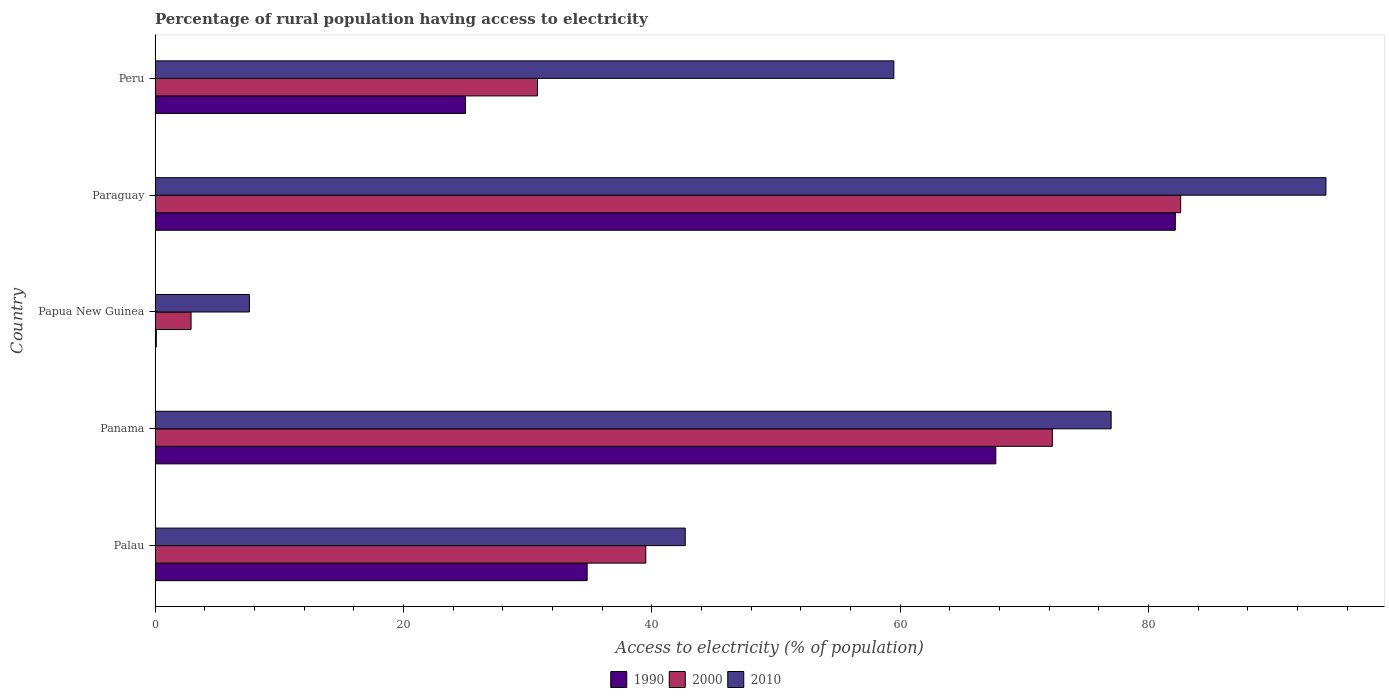How many different coloured bars are there?
Your response must be concise. 3. What is the label of the 2nd group of bars from the top?
Give a very brief answer. Paraguay. In how many cases, is the number of bars for a given country not equal to the number of legend labels?
Ensure brevity in your answer.  0. What is the percentage of rural population having access to electricity in 1990 in Paraguay?
Make the answer very short. 82.17. Across all countries, what is the maximum percentage of rural population having access to electricity in 1990?
Provide a short and direct response. 82.17. In which country was the percentage of rural population having access to electricity in 1990 maximum?
Offer a very short reply. Paraguay. In which country was the percentage of rural population having access to electricity in 2000 minimum?
Give a very brief answer. Papua New Guinea. What is the total percentage of rural population having access to electricity in 2000 in the graph?
Ensure brevity in your answer.  228.09. What is the difference between the percentage of rural population having access to electricity in 2000 in Panama and that in Paraguay?
Make the answer very short. -10.33. What is the difference between the percentage of rural population having access to electricity in 1990 in Papua New Guinea and the percentage of rural population having access to electricity in 2010 in Palau?
Make the answer very short. -42.6. What is the average percentage of rural population having access to electricity in 2010 per country?
Ensure brevity in your answer.  56.22. What is the difference between the percentage of rural population having access to electricity in 2000 and percentage of rural population having access to electricity in 1990 in Peru?
Provide a succinct answer. 5.8. In how many countries, is the percentage of rural population having access to electricity in 1990 greater than 8 %?
Your answer should be very brief. 4. What is the ratio of the percentage of rural population having access to electricity in 2000 in Panama to that in Papua New Guinea?
Make the answer very short. 24.92. Is the difference between the percentage of rural population having access to electricity in 2000 in Panama and Paraguay greater than the difference between the percentage of rural population having access to electricity in 1990 in Panama and Paraguay?
Give a very brief answer. Yes. What is the difference between the highest and the second highest percentage of rural population having access to electricity in 2010?
Ensure brevity in your answer.  17.3. What is the difference between the highest and the lowest percentage of rural population having access to electricity in 2010?
Your answer should be compact. 86.7. Is the sum of the percentage of rural population having access to electricity in 1990 in Papua New Guinea and Paraguay greater than the maximum percentage of rural population having access to electricity in 2000 across all countries?
Offer a terse response. No. What does the 3rd bar from the bottom in Peru represents?
Keep it short and to the point. 2010. Are all the bars in the graph horizontal?
Give a very brief answer. Yes. How many countries are there in the graph?
Your response must be concise. 5. What is the difference between two consecutive major ticks on the X-axis?
Offer a very short reply. 20. Where does the legend appear in the graph?
Your response must be concise. Bottom center. How are the legend labels stacked?
Keep it short and to the point. Horizontal. What is the title of the graph?
Offer a terse response. Percentage of rural population having access to electricity. Does "2013" appear as one of the legend labels in the graph?
Your response must be concise. No. What is the label or title of the X-axis?
Give a very brief answer. Access to electricity (% of population). What is the label or title of the Y-axis?
Provide a succinct answer. Country. What is the Access to electricity (% of population) in 1990 in Palau?
Your answer should be compact. 34.8. What is the Access to electricity (% of population) in 2000 in Palau?
Your answer should be compact. 39.52. What is the Access to electricity (% of population) of 2010 in Palau?
Your answer should be very brief. 42.7. What is the Access to electricity (% of population) in 1990 in Panama?
Make the answer very short. 67.71. What is the Access to electricity (% of population) of 2000 in Panama?
Your answer should be very brief. 72.27. What is the Access to electricity (% of population) of 2010 in Panama?
Provide a succinct answer. 77. What is the Access to electricity (% of population) of 2000 in Papua New Guinea?
Keep it short and to the point. 2.9. What is the Access to electricity (% of population) in 2010 in Papua New Guinea?
Provide a short and direct response. 7.6. What is the Access to electricity (% of population) in 1990 in Paraguay?
Make the answer very short. 82.17. What is the Access to electricity (% of population) of 2000 in Paraguay?
Provide a succinct answer. 82.6. What is the Access to electricity (% of population) of 2010 in Paraguay?
Provide a short and direct response. 94.3. What is the Access to electricity (% of population) in 1990 in Peru?
Your answer should be compact. 25. What is the Access to electricity (% of population) of 2000 in Peru?
Ensure brevity in your answer.  30.8. What is the Access to electricity (% of population) of 2010 in Peru?
Give a very brief answer. 59.5. Across all countries, what is the maximum Access to electricity (% of population) of 1990?
Give a very brief answer. 82.17. Across all countries, what is the maximum Access to electricity (% of population) in 2000?
Ensure brevity in your answer.  82.6. Across all countries, what is the maximum Access to electricity (% of population) in 2010?
Offer a very short reply. 94.3. Across all countries, what is the minimum Access to electricity (% of population) in 2000?
Your answer should be very brief. 2.9. Across all countries, what is the minimum Access to electricity (% of population) of 2010?
Ensure brevity in your answer.  7.6. What is the total Access to electricity (% of population) of 1990 in the graph?
Your answer should be very brief. 209.78. What is the total Access to electricity (% of population) in 2000 in the graph?
Offer a very short reply. 228.09. What is the total Access to electricity (% of population) in 2010 in the graph?
Make the answer very short. 281.1. What is the difference between the Access to electricity (% of population) of 1990 in Palau and that in Panama?
Provide a succinct answer. -32.91. What is the difference between the Access to electricity (% of population) of 2000 in Palau and that in Panama?
Provide a succinct answer. -32.74. What is the difference between the Access to electricity (% of population) of 2010 in Palau and that in Panama?
Provide a succinct answer. -34.3. What is the difference between the Access to electricity (% of population) in 1990 in Palau and that in Papua New Guinea?
Keep it short and to the point. 34.7. What is the difference between the Access to electricity (% of population) in 2000 in Palau and that in Papua New Guinea?
Provide a short and direct response. 36.62. What is the difference between the Access to electricity (% of population) of 2010 in Palau and that in Papua New Guinea?
Ensure brevity in your answer.  35.1. What is the difference between the Access to electricity (% of population) in 1990 in Palau and that in Paraguay?
Offer a very short reply. -47.37. What is the difference between the Access to electricity (% of population) in 2000 in Palau and that in Paraguay?
Offer a terse response. -43.08. What is the difference between the Access to electricity (% of population) of 2010 in Palau and that in Paraguay?
Offer a terse response. -51.6. What is the difference between the Access to electricity (% of population) in 1990 in Palau and that in Peru?
Keep it short and to the point. 9.8. What is the difference between the Access to electricity (% of population) of 2000 in Palau and that in Peru?
Provide a short and direct response. 8.72. What is the difference between the Access to electricity (% of population) of 2010 in Palau and that in Peru?
Ensure brevity in your answer.  -16.8. What is the difference between the Access to electricity (% of population) in 1990 in Panama and that in Papua New Guinea?
Make the answer very short. 67.61. What is the difference between the Access to electricity (% of population) of 2000 in Panama and that in Papua New Guinea?
Offer a terse response. 69.36. What is the difference between the Access to electricity (% of population) in 2010 in Panama and that in Papua New Guinea?
Ensure brevity in your answer.  69.4. What is the difference between the Access to electricity (% of population) of 1990 in Panama and that in Paraguay?
Offer a very short reply. -14.46. What is the difference between the Access to electricity (% of population) of 2000 in Panama and that in Paraguay?
Make the answer very short. -10.34. What is the difference between the Access to electricity (% of population) of 2010 in Panama and that in Paraguay?
Keep it short and to the point. -17.3. What is the difference between the Access to electricity (% of population) of 1990 in Panama and that in Peru?
Keep it short and to the point. 42.71. What is the difference between the Access to electricity (% of population) of 2000 in Panama and that in Peru?
Your answer should be very brief. 41.47. What is the difference between the Access to electricity (% of population) in 1990 in Papua New Guinea and that in Paraguay?
Provide a short and direct response. -82.07. What is the difference between the Access to electricity (% of population) in 2000 in Papua New Guinea and that in Paraguay?
Make the answer very short. -79.7. What is the difference between the Access to electricity (% of population) in 2010 in Papua New Guinea and that in Paraguay?
Ensure brevity in your answer.  -86.7. What is the difference between the Access to electricity (% of population) of 1990 in Papua New Guinea and that in Peru?
Provide a succinct answer. -24.9. What is the difference between the Access to electricity (% of population) in 2000 in Papua New Guinea and that in Peru?
Keep it short and to the point. -27.9. What is the difference between the Access to electricity (% of population) in 2010 in Papua New Guinea and that in Peru?
Your response must be concise. -51.9. What is the difference between the Access to electricity (% of population) of 1990 in Paraguay and that in Peru?
Your answer should be very brief. 57.17. What is the difference between the Access to electricity (% of population) of 2000 in Paraguay and that in Peru?
Your answer should be very brief. 51.8. What is the difference between the Access to electricity (% of population) in 2010 in Paraguay and that in Peru?
Make the answer very short. 34.8. What is the difference between the Access to electricity (% of population) in 1990 in Palau and the Access to electricity (% of population) in 2000 in Panama?
Keep it short and to the point. -37.47. What is the difference between the Access to electricity (% of population) of 1990 in Palau and the Access to electricity (% of population) of 2010 in Panama?
Offer a very short reply. -42.2. What is the difference between the Access to electricity (% of population) of 2000 in Palau and the Access to electricity (% of population) of 2010 in Panama?
Provide a succinct answer. -37.48. What is the difference between the Access to electricity (% of population) of 1990 in Palau and the Access to electricity (% of population) of 2000 in Papua New Guinea?
Give a very brief answer. 31.9. What is the difference between the Access to electricity (% of population) of 1990 in Palau and the Access to electricity (% of population) of 2010 in Papua New Guinea?
Offer a terse response. 27.2. What is the difference between the Access to electricity (% of population) of 2000 in Palau and the Access to electricity (% of population) of 2010 in Papua New Guinea?
Give a very brief answer. 31.92. What is the difference between the Access to electricity (% of population) in 1990 in Palau and the Access to electricity (% of population) in 2000 in Paraguay?
Give a very brief answer. -47.8. What is the difference between the Access to electricity (% of population) of 1990 in Palau and the Access to electricity (% of population) of 2010 in Paraguay?
Your answer should be very brief. -59.5. What is the difference between the Access to electricity (% of population) of 2000 in Palau and the Access to electricity (% of population) of 2010 in Paraguay?
Offer a very short reply. -54.78. What is the difference between the Access to electricity (% of population) of 1990 in Palau and the Access to electricity (% of population) of 2000 in Peru?
Make the answer very short. 4. What is the difference between the Access to electricity (% of population) in 1990 in Palau and the Access to electricity (% of population) in 2010 in Peru?
Offer a terse response. -24.7. What is the difference between the Access to electricity (% of population) of 2000 in Palau and the Access to electricity (% of population) of 2010 in Peru?
Offer a very short reply. -19.98. What is the difference between the Access to electricity (% of population) in 1990 in Panama and the Access to electricity (% of population) in 2000 in Papua New Guinea?
Give a very brief answer. 64.81. What is the difference between the Access to electricity (% of population) of 1990 in Panama and the Access to electricity (% of population) of 2010 in Papua New Guinea?
Provide a succinct answer. 60.11. What is the difference between the Access to electricity (% of population) in 2000 in Panama and the Access to electricity (% of population) in 2010 in Papua New Guinea?
Your response must be concise. 64.67. What is the difference between the Access to electricity (% of population) of 1990 in Panama and the Access to electricity (% of population) of 2000 in Paraguay?
Your answer should be very brief. -14.89. What is the difference between the Access to electricity (% of population) of 1990 in Panama and the Access to electricity (% of population) of 2010 in Paraguay?
Your response must be concise. -26.59. What is the difference between the Access to electricity (% of population) of 2000 in Panama and the Access to electricity (% of population) of 2010 in Paraguay?
Your answer should be compact. -22.04. What is the difference between the Access to electricity (% of population) of 1990 in Panama and the Access to electricity (% of population) of 2000 in Peru?
Give a very brief answer. 36.91. What is the difference between the Access to electricity (% of population) of 1990 in Panama and the Access to electricity (% of population) of 2010 in Peru?
Provide a short and direct response. 8.21. What is the difference between the Access to electricity (% of population) in 2000 in Panama and the Access to electricity (% of population) in 2010 in Peru?
Your answer should be very brief. 12.77. What is the difference between the Access to electricity (% of population) of 1990 in Papua New Guinea and the Access to electricity (% of population) of 2000 in Paraguay?
Keep it short and to the point. -82.5. What is the difference between the Access to electricity (% of population) in 1990 in Papua New Guinea and the Access to electricity (% of population) in 2010 in Paraguay?
Offer a terse response. -94.2. What is the difference between the Access to electricity (% of population) in 2000 in Papua New Guinea and the Access to electricity (% of population) in 2010 in Paraguay?
Ensure brevity in your answer.  -91.4. What is the difference between the Access to electricity (% of population) in 1990 in Papua New Guinea and the Access to electricity (% of population) in 2000 in Peru?
Offer a very short reply. -30.7. What is the difference between the Access to electricity (% of population) in 1990 in Papua New Guinea and the Access to electricity (% of population) in 2010 in Peru?
Ensure brevity in your answer.  -59.4. What is the difference between the Access to electricity (% of population) in 2000 in Papua New Guinea and the Access to electricity (% of population) in 2010 in Peru?
Provide a short and direct response. -56.6. What is the difference between the Access to electricity (% of population) of 1990 in Paraguay and the Access to electricity (% of population) of 2000 in Peru?
Your answer should be compact. 51.37. What is the difference between the Access to electricity (% of population) in 1990 in Paraguay and the Access to electricity (% of population) in 2010 in Peru?
Your answer should be compact. 22.67. What is the difference between the Access to electricity (% of population) in 2000 in Paraguay and the Access to electricity (% of population) in 2010 in Peru?
Your answer should be very brief. 23.1. What is the average Access to electricity (% of population) in 1990 per country?
Offer a very short reply. 41.96. What is the average Access to electricity (% of population) in 2000 per country?
Keep it short and to the point. 45.62. What is the average Access to electricity (% of population) in 2010 per country?
Your answer should be very brief. 56.22. What is the difference between the Access to electricity (% of population) of 1990 and Access to electricity (% of population) of 2000 in Palau?
Offer a terse response. -4.72. What is the difference between the Access to electricity (% of population) in 1990 and Access to electricity (% of population) in 2010 in Palau?
Keep it short and to the point. -7.9. What is the difference between the Access to electricity (% of population) in 2000 and Access to electricity (% of population) in 2010 in Palau?
Your response must be concise. -3.18. What is the difference between the Access to electricity (% of population) in 1990 and Access to electricity (% of population) in 2000 in Panama?
Offer a very short reply. -4.55. What is the difference between the Access to electricity (% of population) of 1990 and Access to electricity (% of population) of 2010 in Panama?
Your response must be concise. -9.29. What is the difference between the Access to electricity (% of population) in 2000 and Access to electricity (% of population) in 2010 in Panama?
Make the answer very short. -4.74. What is the difference between the Access to electricity (% of population) of 2000 and Access to electricity (% of population) of 2010 in Papua New Guinea?
Keep it short and to the point. -4.7. What is the difference between the Access to electricity (% of population) of 1990 and Access to electricity (% of population) of 2000 in Paraguay?
Your response must be concise. -0.43. What is the difference between the Access to electricity (% of population) in 1990 and Access to electricity (% of population) in 2010 in Paraguay?
Your answer should be compact. -12.13. What is the difference between the Access to electricity (% of population) in 2000 and Access to electricity (% of population) in 2010 in Paraguay?
Provide a short and direct response. -11.7. What is the difference between the Access to electricity (% of population) of 1990 and Access to electricity (% of population) of 2000 in Peru?
Give a very brief answer. -5.8. What is the difference between the Access to electricity (% of population) of 1990 and Access to electricity (% of population) of 2010 in Peru?
Offer a very short reply. -34.5. What is the difference between the Access to electricity (% of population) of 2000 and Access to electricity (% of population) of 2010 in Peru?
Provide a short and direct response. -28.7. What is the ratio of the Access to electricity (% of population) in 1990 in Palau to that in Panama?
Ensure brevity in your answer.  0.51. What is the ratio of the Access to electricity (% of population) in 2000 in Palau to that in Panama?
Keep it short and to the point. 0.55. What is the ratio of the Access to electricity (% of population) in 2010 in Palau to that in Panama?
Offer a terse response. 0.55. What is the ratio of the Access to electricity (% of population) of 1990 in Palau to that in Papua New Guinea?
Provide a short and direct response. 347.98. What is the ratio of the Access to electricity (% of population) of 2000 in Palau to that in Papua New Guinea?
Give a very brief answer. 13.63. What is the ratio of the Access to electricity (% of population) of 2010 in Palau to that in Papua New Guinea?
Your answer should be compact. 5.62. What is the ratio of the Access to electricity (% of population) of 1990 in Palau to that in Paraguay?
Give a very brief answer. 0.42. What is the ratio of the Access to electricity (% of population) of 2000 in Palau to that in Paraguay?
Provide a short and direct response. 0.48. What is the ratio of the Access to electricity (% of population) of 2010 in Palau to that in Paraguay?
Your response must be concise. 0.45. What is the ratio of the Access to electricity (% of population) in 1990 in Palau to that in Peru?
Give a very brief answer. 1.39. What is the ratio of the Access to electricity (% of population) of 2000 in Palau to that in Peru?
Your answer should be compact. 1.28. What is the ratio of the Access to electricity (% of population) in 2010 in Palau to that in Peru?
Ensure brevity in your answer.  0.72. What is the ratio of the Access to electricity (% of population) of 1990 in Panama to that in Papua New Guinea?
Make the answer very short. 677.11. What is the ratio of the Access to electricity (% of population) in 2000 in Panama to that in Papua New Guinea?
Give a very brief answer. 24.92. What is the ratio of the Access to electricity (% of population) in 2010 in Panama to that in Papua New Guinea?
Provide a short and direct response. 10.13. What is the ratio of the Access to electricity (% of population) of 1990 in Panama to that in Paraguay?
Provide a succinct answer. 0.82. What is the ratio of the Access to electricity (% of population) in 2000 in Panama to that in Paraguay?
Offer a very short reply. 0.87. What is the ratio of the Access to electricity (% of population) of 2010 in Panama to that in Paraguay?
Your response must be concise. 0.82. What is the ratio of the Access to electricity (% of population) in 1990 in Panama to that in Peru?
Offer a terse response. 2.71. What is the ratio of the Access to electricity (% of population) of 2000 in Panama to that in Peru?
Your answer should be compact. 2.35. What is the ratio of the Access to electricity (% of population) in 2010 in Panama to that in Peru?
Offer a terse response. 1.29. What is the ratio of the Access to electricity (% of population) of 1990 in Papua New Guinea to that in Paraguay?
Keep it short and to the point. 0. What is the ratio of the Access to electricity (% of population) in 2000 in Papua New Guinea to that in Paraguay?
Ensure brevity in your answer.  0.04. What is the ratio of the Access to electricity (% of population) of 2010 in Papua New Guinea to that in Paraguay?
Offer a terse response. 0.08. What is the ratio of the Access to electricity (% of population) in 1990 in Papua New Guinea to that in Peru?
Provide a short and direct response. 0. What is the ratio of the Access to electricity (% of population) of 2000 in Papua New Guinea to that in Peru?
Keep it short and to the point. 0.09. What is the ratio of the Access to electricity (% of population) of 2010 in Papua New Guinea to that in Peru?
Offer a terse response. 0.13. What is the ratio of the Access to electricity (% of population) of 1990 in Paraguay to that in Peru?
Offer a very short reply. 3.29. What is the ratio of the Access to electricity (% of population) in 2000 in Paraguay to that in Peru?
Offer a terse response. 2.68. What is the ratio of the Access to electricity (% of population) of 2010 in Paraguay to that in Peru?
Your response must be concise. 1.58. What is the difference between the highest and the second highest Access to electricity (% of population) in 1990?
Your answer should be compact. 14.46. What is the difference between the highest and the second highest Access to electricity (% of population) in 2000?
Make the answer very short. 10.34. What is the difference between the highest and the second highest Access to electricity (% of population) of 2010?
Keep it short and to the point. 17.3. What is the difference between the highest and the lowest Access to electricity (% of population) in 1990?
Keep it short and to the point. 82.07. What is the difference between the highest and the lowest Access to electricity (% of population) of 2000?
Offer a very short reply. 79.7. What is the difference between the highest and the lowest Access to electricity (% of population) of 2010?
Give a very brief answer. 86.7. 